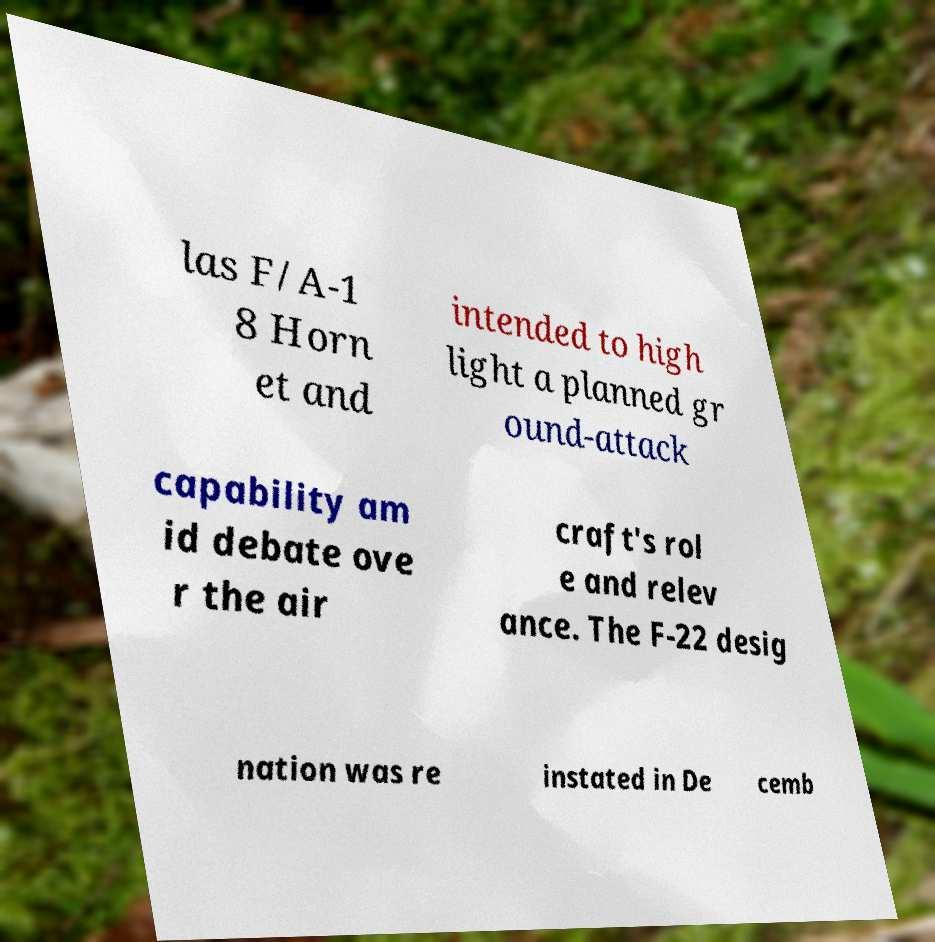Could you extract and type out the text from this image? las F/A-1 8 Horn et and intended to high light a planned gr ound-attack capability am id debate ove r the air craft's rol e and relev ance. The F-22 desig nation was re instated in De cemb 